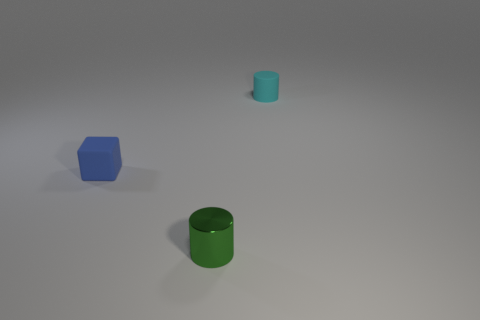Add 1 small yellow things. How many objects exist? 4 Subtract all blocks. How many objects are left? 2 Subtract all matte spheres. Subtract all tiny cyan cylinders. How many objects are left? 2 Add 2 tiny cyan matte objects. How many tiny cyan matte objects are left? 3 Add 1 small cyan matte cylinders. How many small cyan matte cylinders exist? 2 Subtract 0 purple balls. How many objects are left? 3 